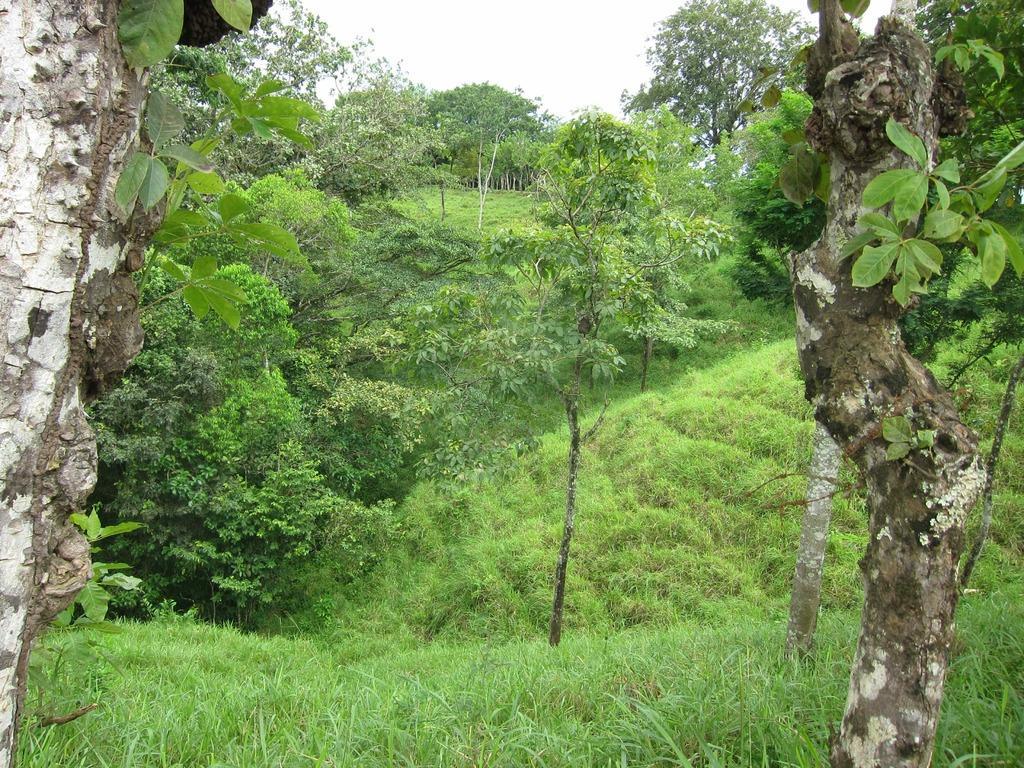Describe this image in one or two sentences. In this image I can see some grass on the ground which is green in color and few trees which are green, white and brown in color. In the background I can see few trees and the sky. 